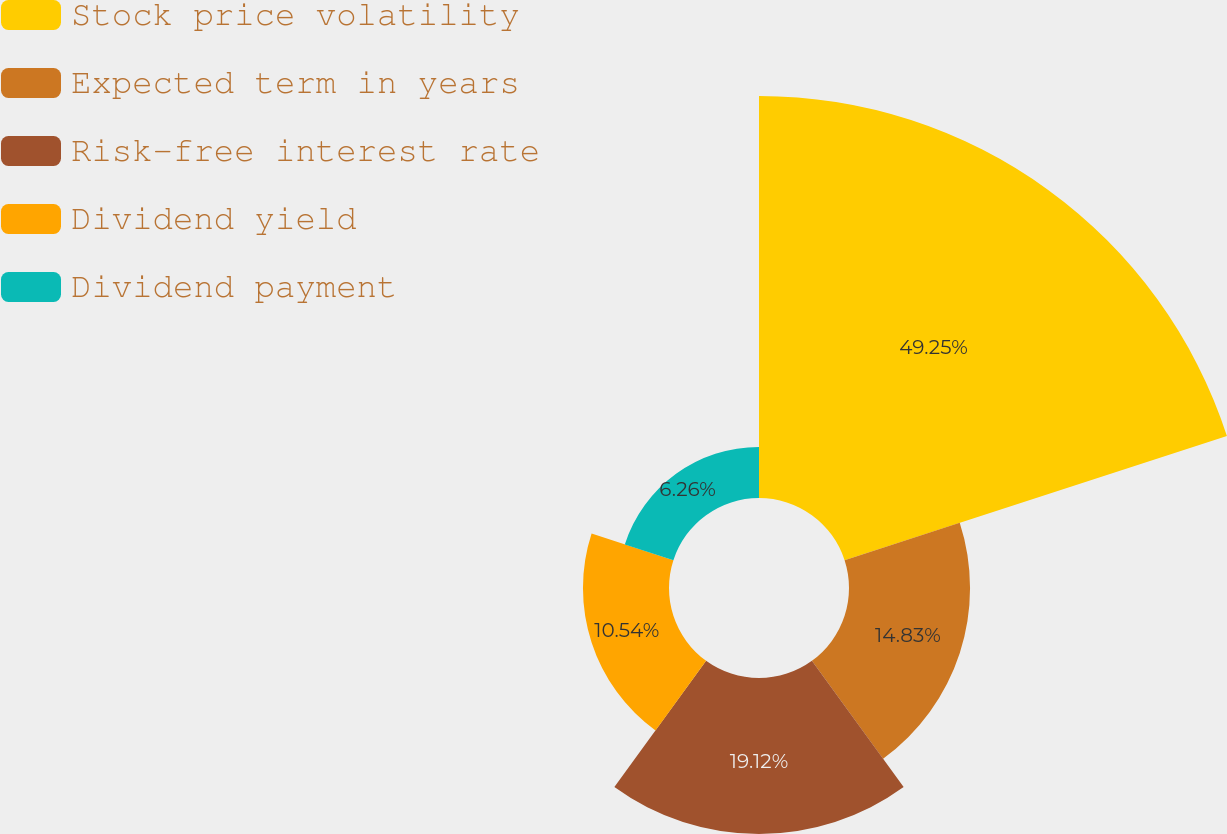<chart> <loc_0><loc_0><loc_500><loc_500><pie_chart><fcel>Stock price volatility<fcel>Expected term in years<fcel>Risk-free interest rate<fcel>Dividend yield<fcel>Dividend payment<nl><fcel>49.25%<fcel>14.83%<fcel>19.12%<fcel>10.54%<fcel>6.26%<nl></chart> 